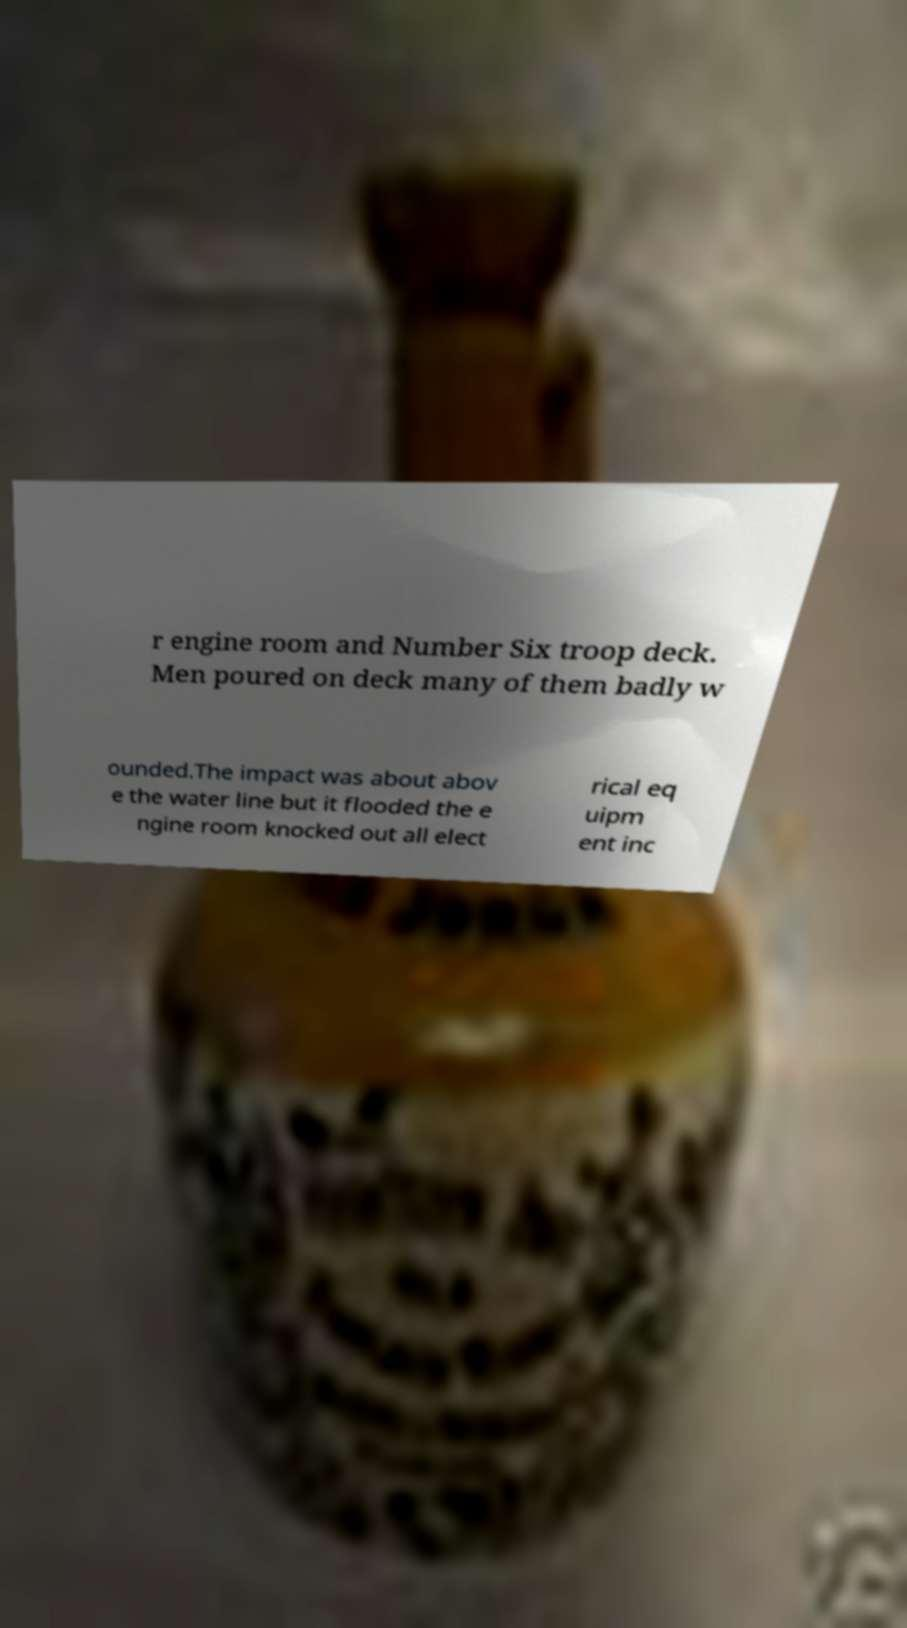There's text embedded in this image that I need extracted. Can you transcribe it verbatim? r engine room and Number Six troop deck. Men poured on deck many of them badly w ounded.The impact was about abov e the water line but it flooded the e ngine room knocked out all elect rical eq uipm ent inc 